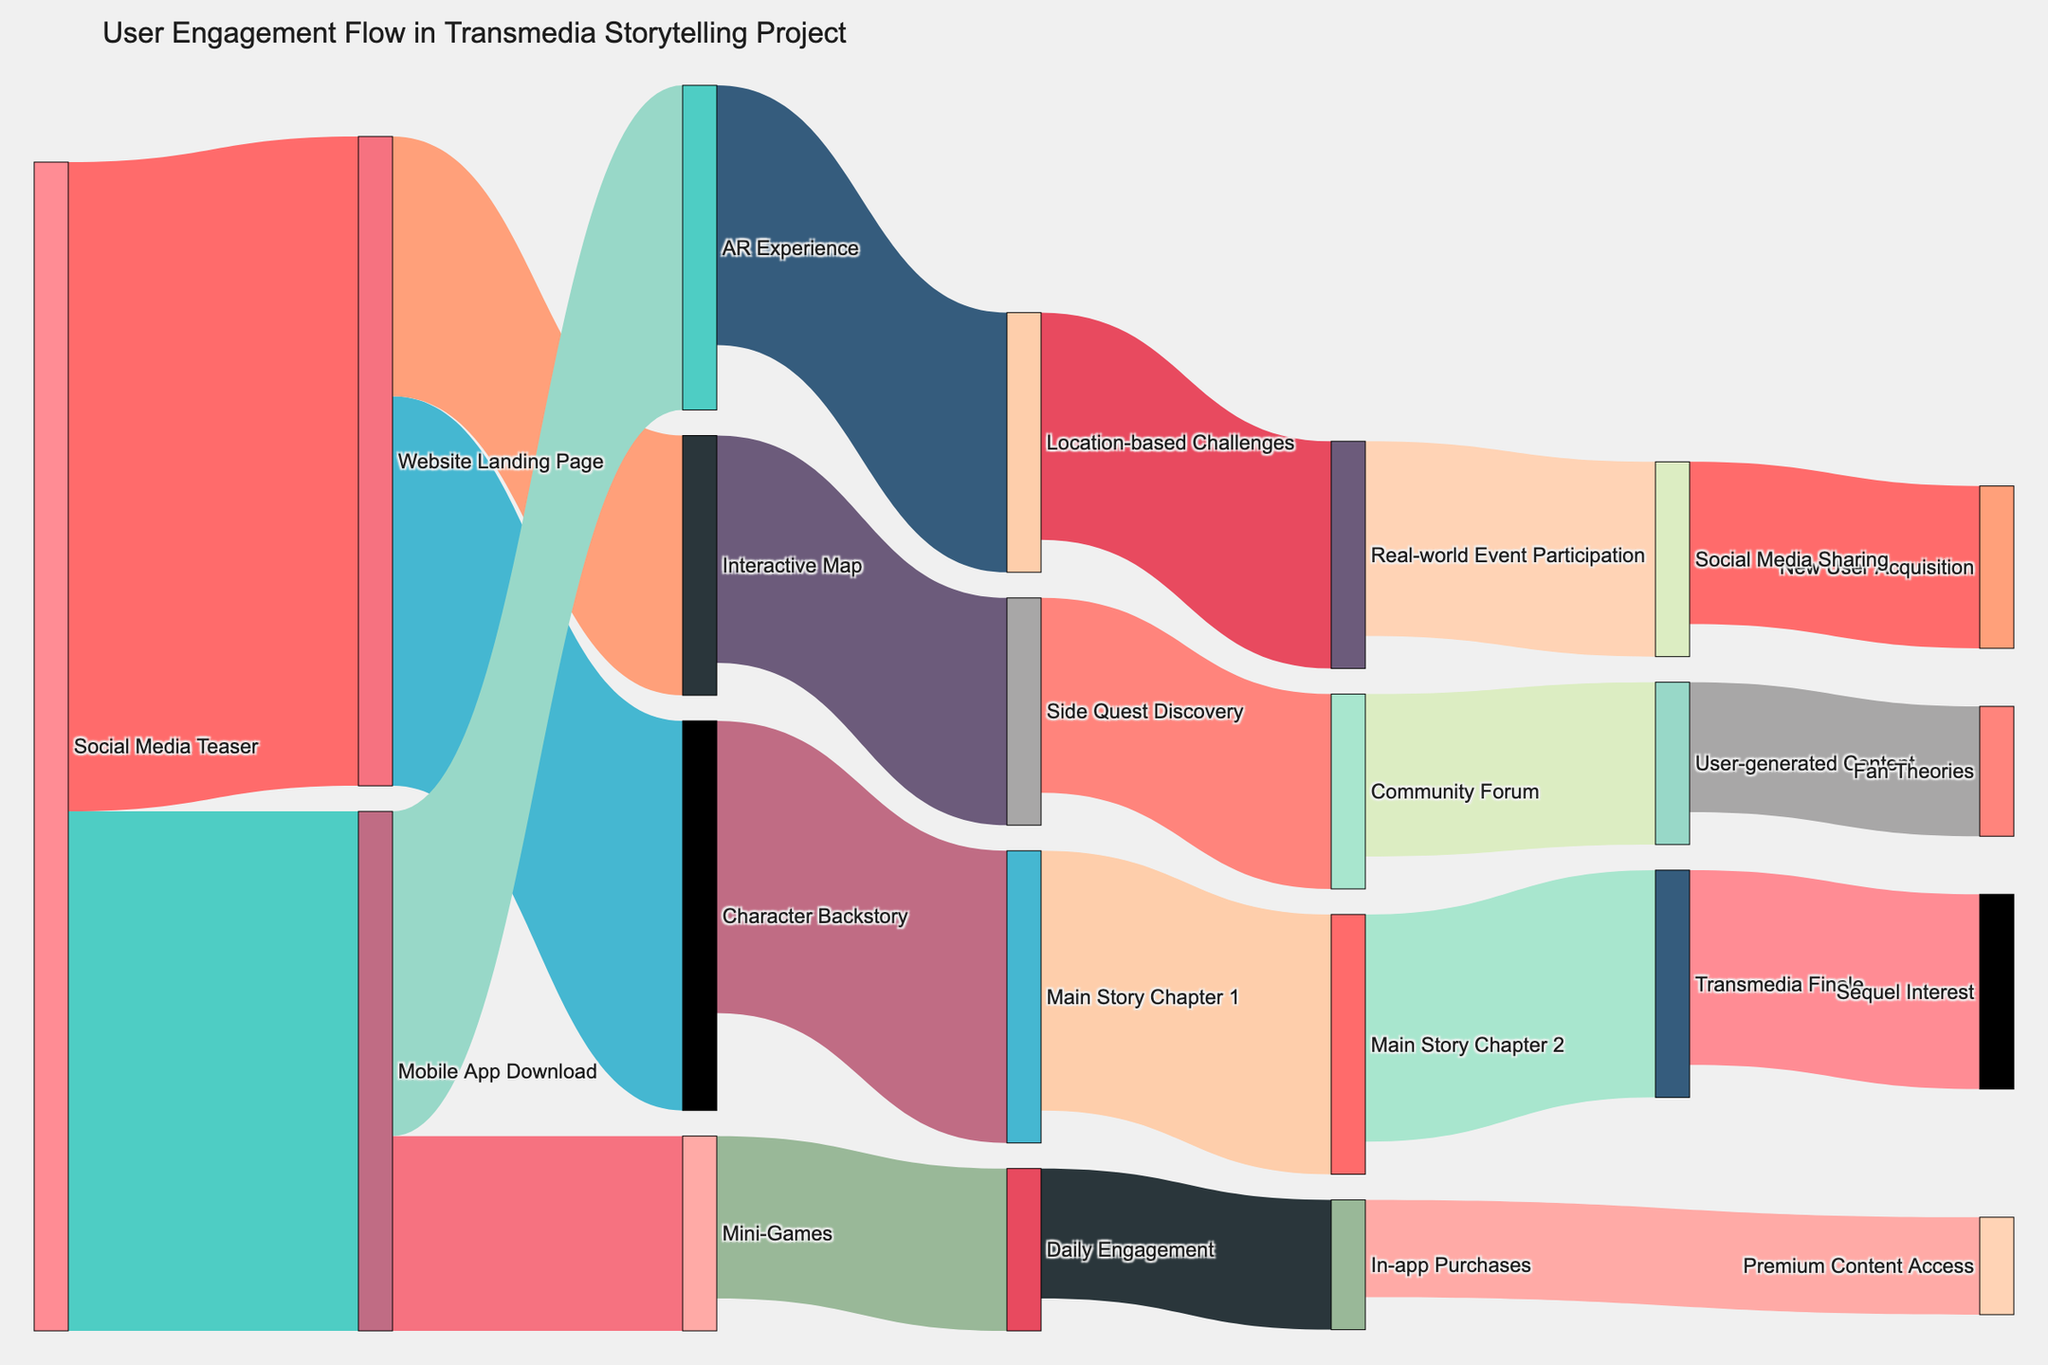What is the title of the diagram? It is displayed at the top of the diagram. The title reads "User Engagement Flow in Transmedia Storytelling Project".
Answer: User Engagement Flow in Transmedia Storytelling Project Which initial engagement source has the highest flow to other components? By observing the source nodes at the beginning of the Sankey diagram, "Social Media Teaser" has the highest combined flow to other components: 1000 to "Website Landing Page" and 800 to "Mobile App Download".
Answer: Social Media Teaser How many users transition from "Mobile App Download" to "AR Experience"? Check the connection from "Mobile App Download" to "AR Experience". The value of this flow is 500.
Answer: 500 What is the sum of users who move from "Website Landing Page" to "Character Backstory" and "Interactive Map"? Add the values of the flows from "Website Landing Page" to "Character Backstory" (600) and to "Interactive Map" (400). The sum is 600 + 400 = 1000.
Answer: 1000 Which interaction has the highest number of users, "Main Story Chapter 1 to Main Story Chapter 2" or "Side Quest Discovery to Community Forum"? Compare the values of the two flows: "Main Story Chapter 1 to Main Story Chapter 2" has 400 users, and "Side Quest Discovery to Community Forum" has 300 users. The higher number is for "Main Story Chapter 1 to Main Story Chapter 2".
Answer: Main Story Chapter 1 to Main Story Chapter 2 What is the value of the user flow from "Real-world Event Participation" to "Social Media Sharing"? Find the flow labeled between "Real-world Event Participation" and "Social Media Sharing". The value is 300.
Answer: 300 Which node has the flow leading to "Sequel Interest"? Trace the flows leading to the node labeled "Sequel Interest". The flow comes from "Transmedia Finale".
Answer: Transmedia Finale What is the total number of users engaging with premium or paid content (including in-app purchases and premium content access)? Sum the values from "Daily Engagement" to "In-app Purchases" (200) and from "In-app Purchases" to "Premium Content Access" (150). The total is 200 + 150 = 350.
Answer: 350 Do more users go from "Website Landing Page" to "Character Backstory" or from "Main Story Chapter 1" to "Main Story Chapter 2"? Compare the values: "Website Landing Page" to "Character Backstory" has 600, while "Main Story Chapter 1" to "Main Story Chapter 2" has 400. More users go from "Website Landing Page" to "Character Backstory".
Answer: Website Landing Page to Character Backstory Which flow represents new user acquisition due to social media sharing? Identify the flow labeled "New User Acquisition" that connects from "Social Media Sharing". The value is 250.
Answer: New User Acquisition 